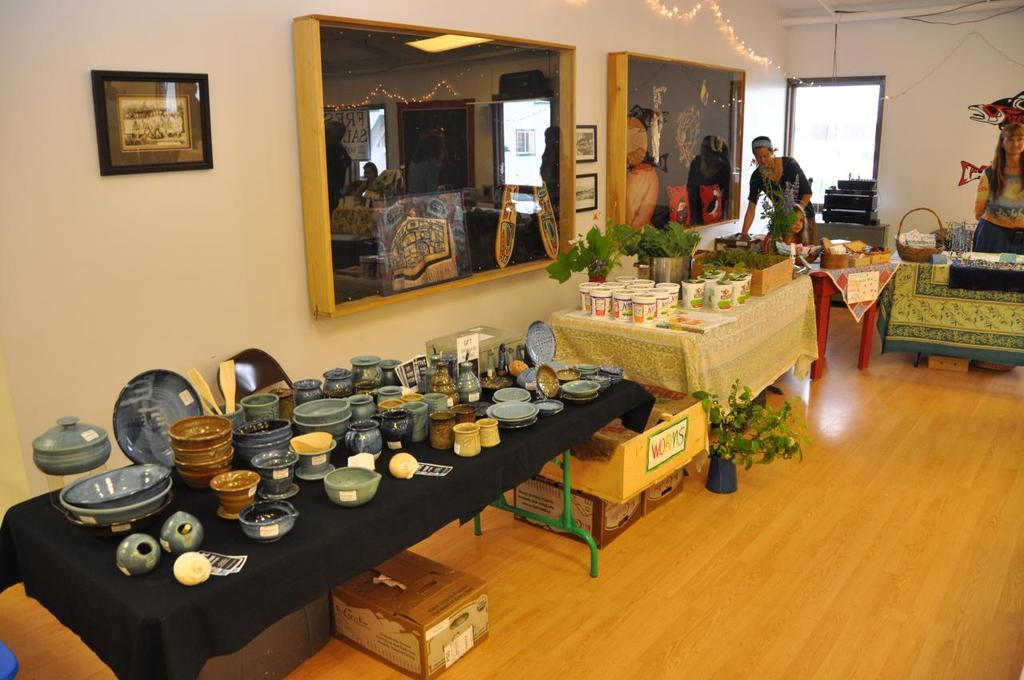What type of furniture is present in the image? There are tables in the image. What can be found on top of the tables? There are objects on the tables. Can you describe the people in the image? There are people in the image. What type of vegetation is present in the image? There are plants in the image. What type of clothing is worn by some of the people in the image? There are boxers in the image, which suggests that some people are wearing boxer shorts. What is hanging on the wall in the image? There is a frame on the wall in the image. What type of oil can be seen dripping from the boxers in the image? There is no oil present in the image, and the boxers are not depicted as dripping with any substance. Can you tell me how many brothers are present in the image? The provided facts do not mention any brothers, so it cannot be determined from the image. 